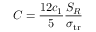<formula> <loc_0><loc_0><loc_500><loc_500>C = \frac { 1 2 c _ { 1 } } { 5 } \frac { S _ { R } } { \sigma _ { t r } }</formula> 